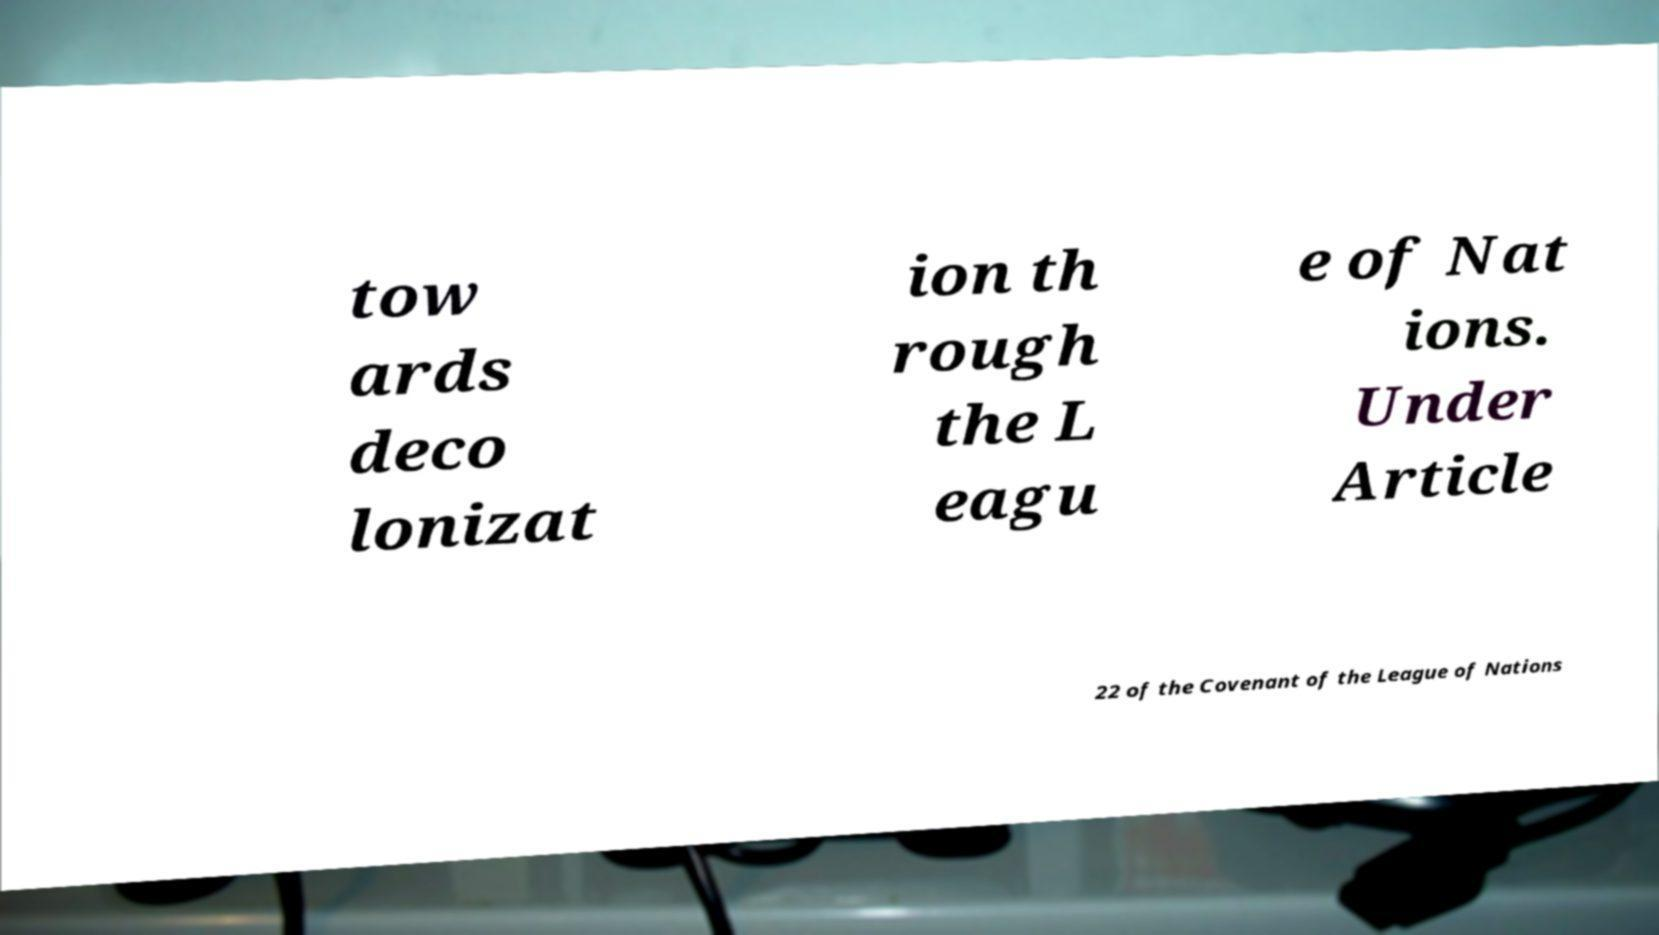Can you accurately transcribe the text from the provided image for me? tow ards deco lonizat ion th rough the L eagu e of Nat ions. Under Article 22 of the Covenant of the League of Nations 